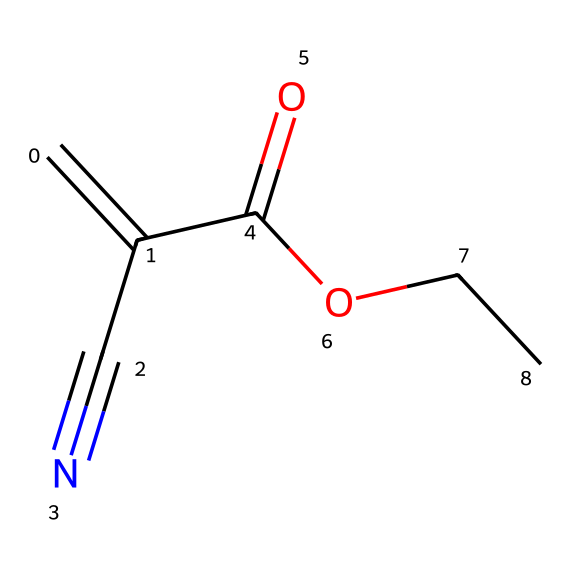What is the main functional group in this chemical? The chemical structure contains a cyano group (-C≡N) and a carboxylic acid group (-COOH). The cyano group is the main functional group present in this molecule, characteristic of nitriles.
Answer: cyano group How many carbon atoms are in the molecule? Counting the carbon atoms from the SMILES representation, we identify four carbon atoms connected in a chain, along with one carbon in the cyano group. Therefore, there are a total of five carbon atoms.
Answer: five What is the total number of hydrogen atoms in this chemical? Analyzing the structure, for each carbon atom, we determine the number of hydrogen atoms according to tetravalency. The carboxylic group contributes one hydrogen, while carbon at the triple bond will not add further. The total number comes to eight hydrogens.
Answer: eight Which element indicates the compound's nitrile classification? The presence of the nitrogen atom in the cyano group (-C≡N) distinctly classifies this compound as a nitrile, as nitriles are defined by having a carbon atom triple-bonded to a nitrogen atom.
Answer: nitrogen What type of bonding is present between the carbon and nitrogen in the cyano group? In the cyano group, the bonding between carbon and nitrogen is a triple bond, which consists of one sigma bond and two pi bonds, a characteristic feature that differentiates cyano compounds.
Answer: triple bond What is the hybridization state of the carbon in the cyano group? The carbon atom in the cyano group is sp hybridized due to the triple bond with nitrogen, which involves two pi bonds and one sigma bond, resulting in a linear geometry.
Answer: sp How does the carboxylic acid group contribute to the adhesive properties? The carboxylic acid group can form hydrogen bonds with substrates, enhancing adhesion capabilities due to increased interaction, making it crucial for the bonding properties of fast-drying adhesives.
Answer: hydrogen bonds 